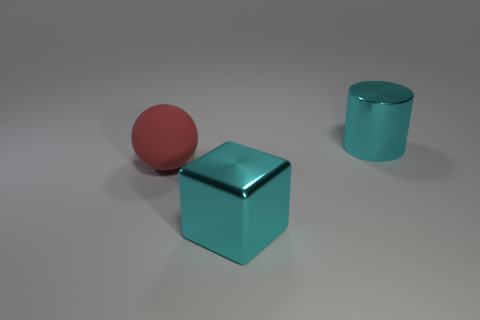Add 3 large red spheres. How many objects exist? 6 Subtract all cubes. How many objects are left? 2 Subtract all purple metallic blocks. Subtract all large cyan things. How many objects are left? 1 Add 3 cyan metallic cylinders. How many cyan metallic cylinders are left? 4 Add 3 cyan cylinders. How many cyan cylinders exist? 4 Subtract 0 gray cylinders. How many objects are left? 3 